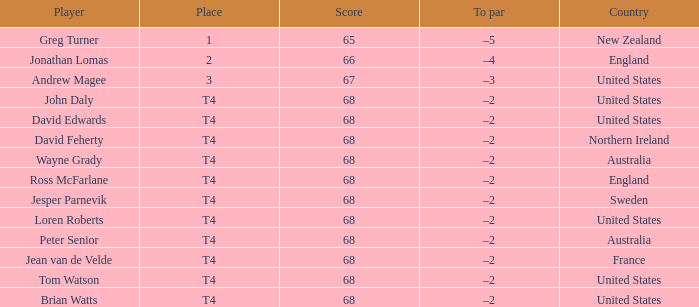Name the Score united states of tom watson in united state? 68.0. 